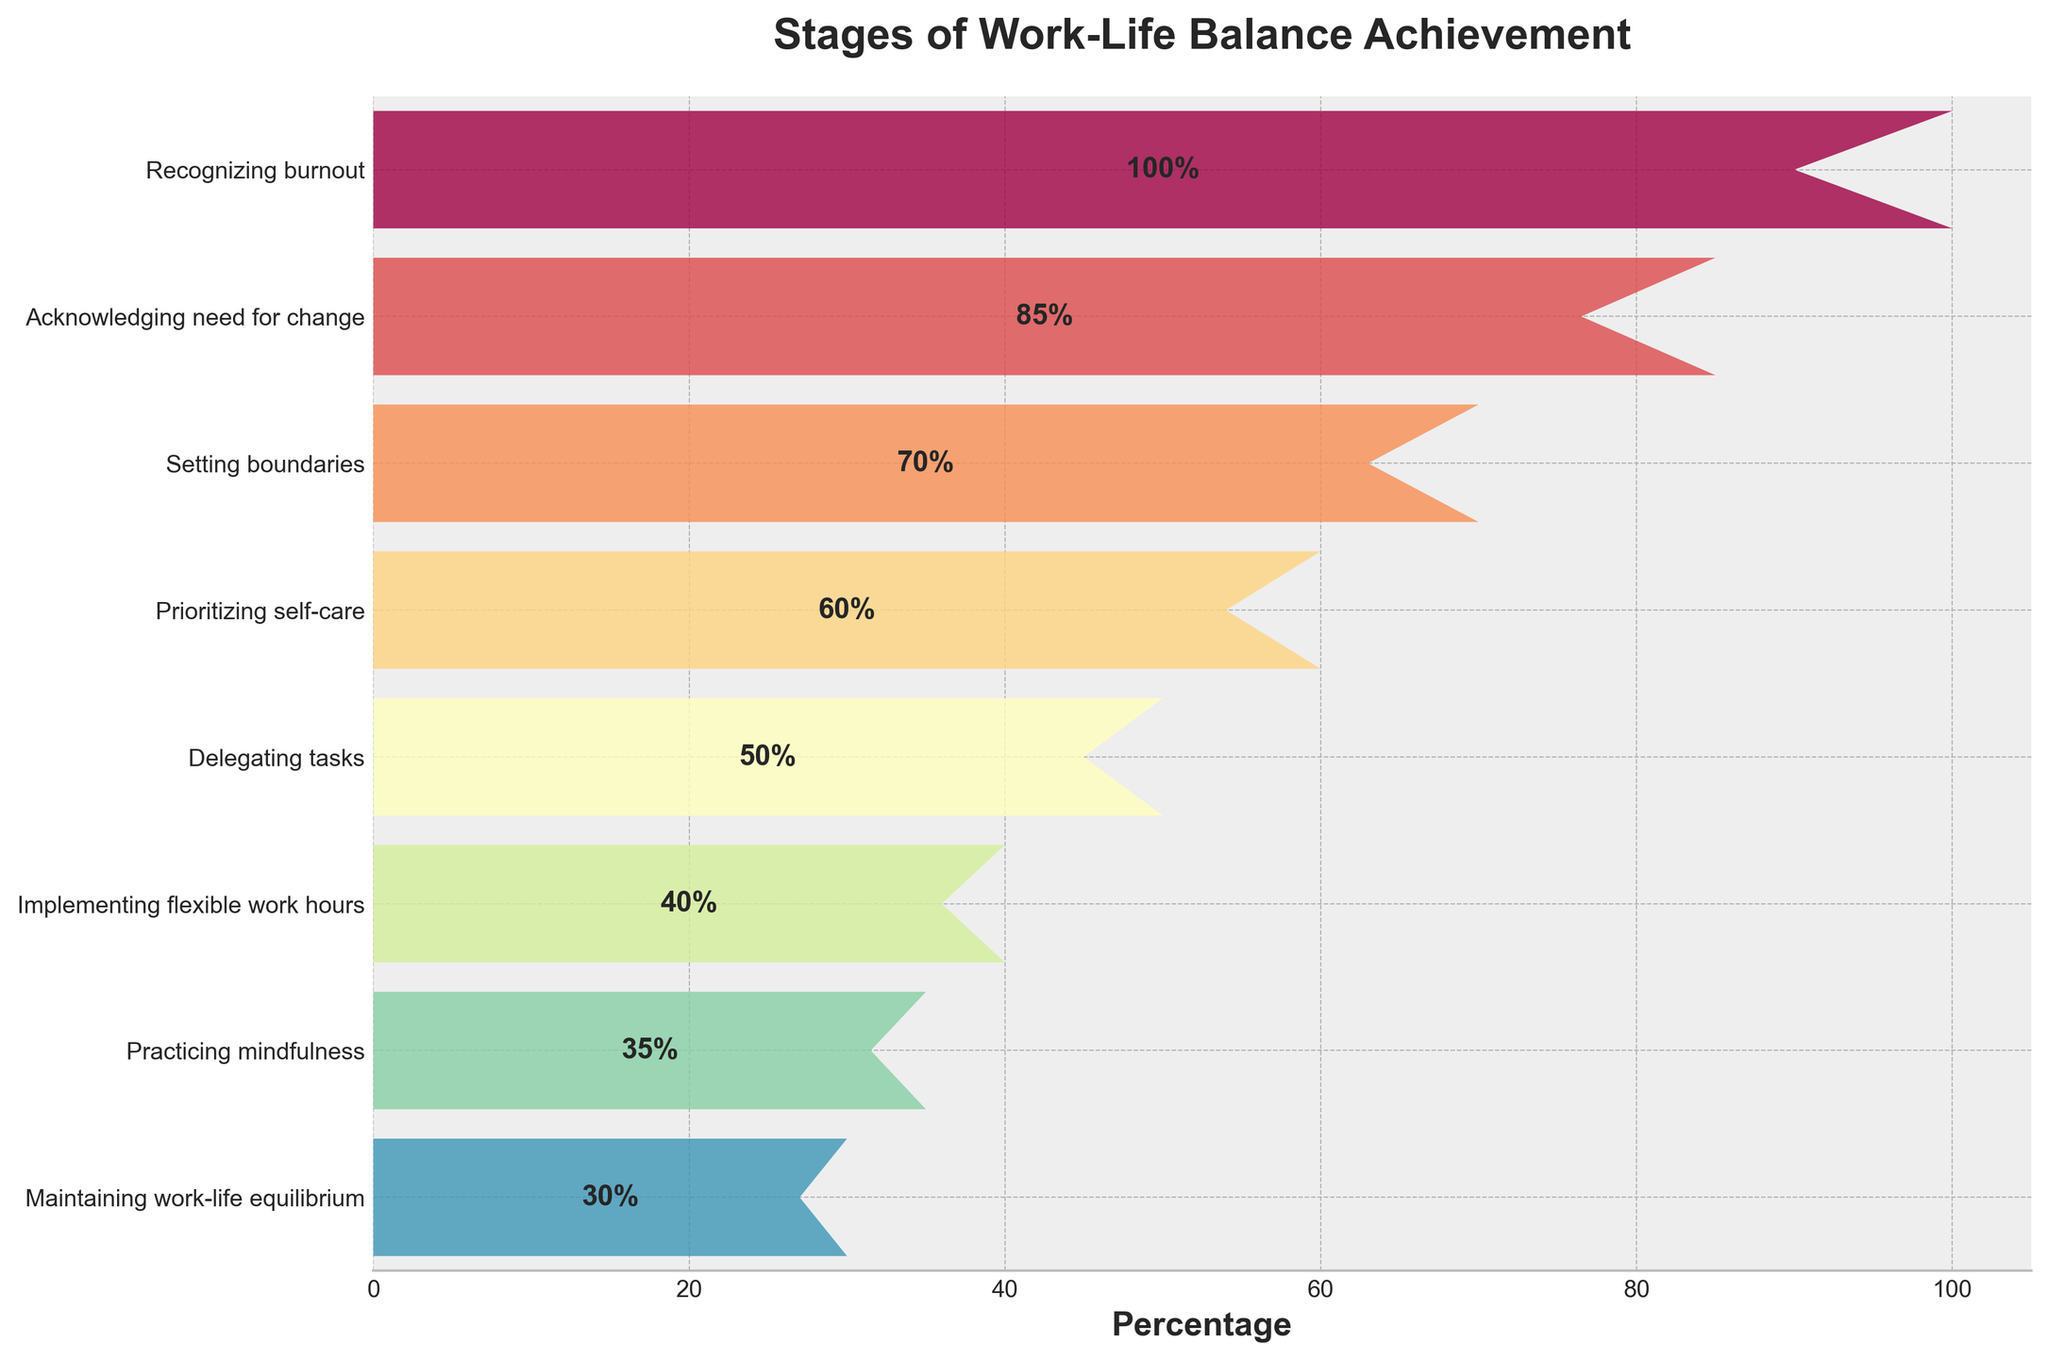what's the title of the figure? The title of a figure is usually displayed prominently at the top. By looking at the top of the rendered figure, you can identify the title.
Answer: Stages of Work-Life Balance Achievement How many stages are shown in the funnel chart? Count the number of distinct stages listed along the y-axis from top to bottom.
Answer: 8 Which stage has the highest percentage? Look for the widest segment of the funnel chart, which represents the highest percentage.
Answer: Recognizing burnout What is the percentage difference between 'Setting boundaries' and 'Delegating tasks'? Find the percentages for both 'Setting boundaries' and 'Delegating tasks', then subtract the latter from the former: 70% - 50%.
Answer: 20% Are there more than half the people implementing flexible work hours compared to those prioritizing self-care? The 'Implementing flexible work hours' percentage is 40%, and the 'Prioritizing self-care' percentage is 60%. Compare 40% with half of 60%, which is 30%.
Answer: Yes What trend do you observe in the percentages as you move down the stages? Examine the progression of percentages from top (highest stage) to bottom (lowest stage).
Answer: The percentages decrease Which stage is immediately after 'Acknowledging need for change'? Identify the stage that is directly below 'Acknowledging need for change' on the y-axis.
Answer: Setting boundaries How many stages have a percentage lower than 'Acknowledging need for change'? Find the percentage for 'Acknowledging need for change' (85%), then count how many stages have a percentage lower than 85%.
Answer: 6 Is 'Practicing mindfulness' more common than 'Delegating tasks'? Compare the percentage for 'Practicing mindfulness' (35%) with that for 'Delegating tasks' (50%).
Answer: No What is the median percentage in the data? List the percentages in numerical order: 30%, 35%, 40%, 50%, 60%, 70%, 85%, 100%. Since there are 8 data points, the median is the average of the 4th and 5th values. (50% + 60%) / 2.
Answer: 55% 